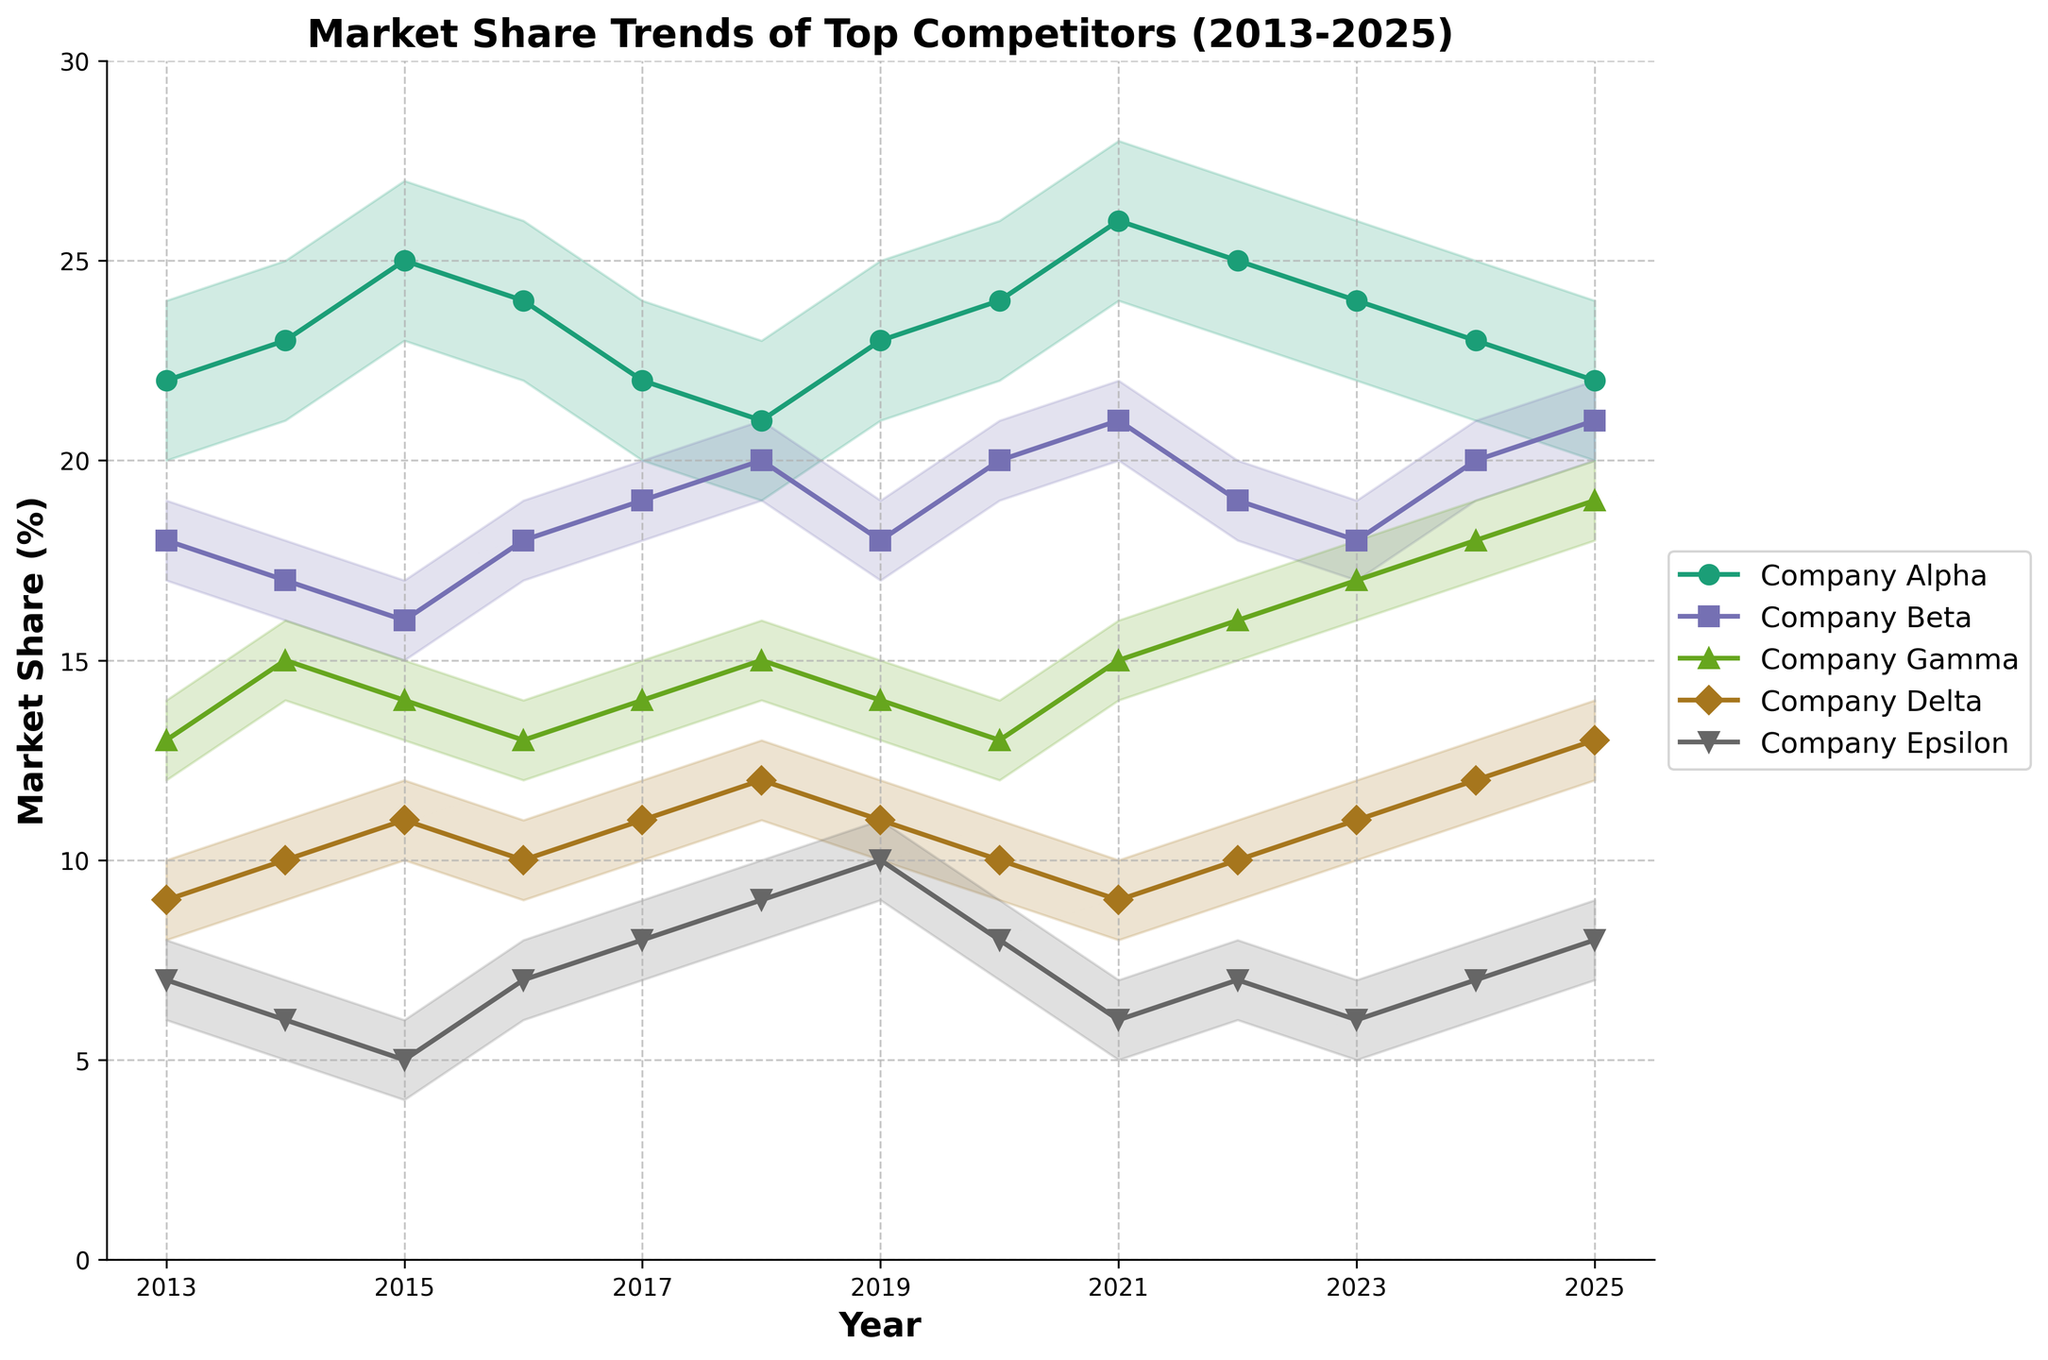How many companies are compared in the figure? The title mentions "Top Competitors," and looking at the legend, there are five different colors and markers representing five distinct companies: Company Alpha, Beta, Gamma, Delta, and Epsilon.
Answer: Five What is the overall trend of Company Alpha's market share from 2013 to 2025? By observing the line associated with Company Alpha, it shows an upward trend initially from 2013 to 2021, peaks in 2021, and then gradually declines till 2025.
Answer: Peaks in 2021, then declines Which company has the least market share in 2025? Looking at the data points for the year 2025, Company Epsilon has the lowest market share percentage among the companies listed.
Answer: Company Epsilon What is the confidence interval for Company Beta's market share in 2020? Referring to the error bars for Company Beta in the year 2020, the market share confidence interval ranges from 19% to 21%.
Answer: 19% to 21% Which company saw the most consistent market share from 2013 to 2025? Observing all the lines, Company Delta's line appears to be the most stable with minimal fluctuation compared to other companies over the years.
Answer: Company Delta By how much did Company Gamma's market share change from 2022 to 2023? Company Gamma's market share increased from 16% in 2022 to 17% in 2023. The change is calculated as 17 - 16 = 1%.
Answer: Increased by 1% Which company has the highest market share in 2018? Observing the data points for the year 2018, Company Beta has the highest market share at 20%.
Answer: Company Beta Does any company have a market share greater than 25% at any point? Company Alpha has a market share greater than 25% in 2021 (26%). No other company reaches this level.
Answer: Company Alpha in 2021 (26%) In which year did Company Epsilon have its highest market share? Checking the data points for Company Epsilon, the highest market share was in 2019 at 10%.
Answer: 2019 Which company shows a steady increase in market share from 2023 to 2025? Company Gamma's market share shows a consistent increase from 17% in 2023, to 18% in 2024, and then 19% in 2025.
Answer: Company Gamma 